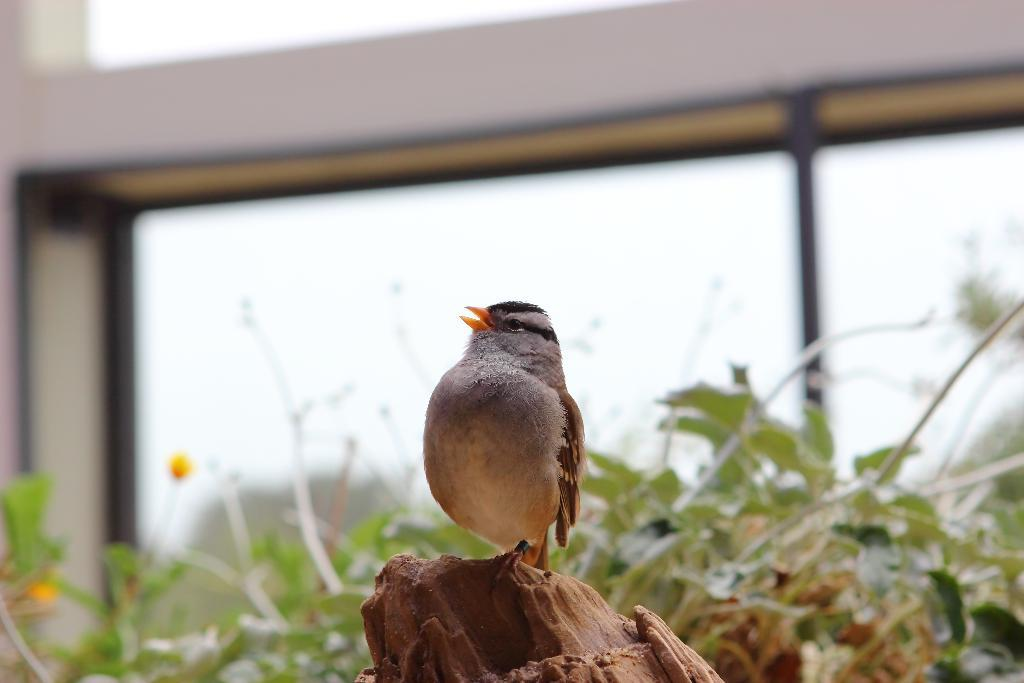What is the main subject in the foreground of the image? There is a bird in the foreground of the image. Where is the bird located? The bird is on a tree. What can be seen in the background of the image? There are plants and a glass window in the background of the image. What type of structure is visible in the background? There is a wall in the background of the image. What type of approval does the bird have for its actions in the image? There is no indication of approval or disapproval in the image, as it is a photograph of a bird on a tree. Can you see a badge on the bird in the image? There is no badge visible on the bird in the image. 